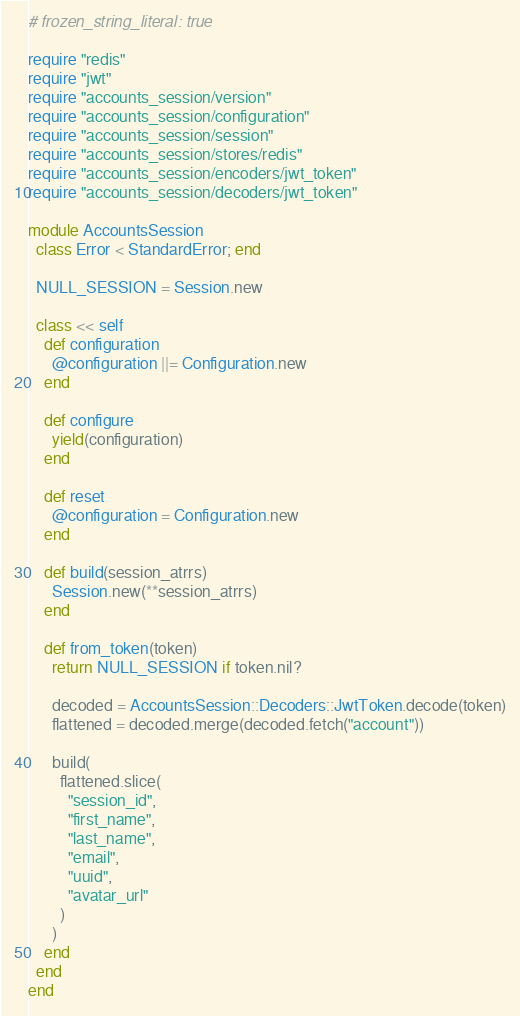Convert code to text. <code><loc_0><loc_0><loc_500><loc_500><_Ruby_># frozen_string_literal: true

require "redis"
require "jwt"
require "accounts_session/version"
require "accounts_session/configuration"
require "accounts_session/session"
require "accounts_session/stores/redis"
require "accounts_session/encoders/jwt_token"
require "accounts_session/decoders/jwt_token"

module AccountsSession
  class Error < StandardError; end

  NULL_SESSION = Session.new

  class << self
    def configuration
      @configuration ||= Configuration.new
    end

    def configure
      yield(configuration)
    end

    def reset
      @configuration = Configuration.new
    end

    def build(session_atrrs)
      Session.new(**session_atrrs)
    end

    def from_token(token)
      return NULL_SESSION if token.nil?

      decoded = AccountsSession::Decoders::JwtToken.decode(token)
      flattened = decoded.merge(decoded.fetch("account"))

      build(
        flattened.slice(
          "session_id",
          "first_name",
          "last_name",
          "email",
          "uuid",
          "avatar_url"
        )
      )
    end
  end
end
</code> 